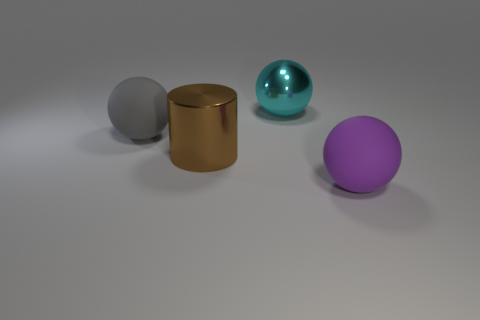Add 1 big brown blocks. How many objects exist? 5 Subtract all large gray spheres. How many spheres are left? 2 Subtract all purple balls. How many balls are left? 2 Subtract all spheres. How many objects are left? 1 Subtract 1 cylinders. How many cylinders are left? 0 Add 1 large brown cylinders. How many large brown cylinders exist? 2 Subtract 0 cyan cubes. How many objects are left? 4 Subtract all blue spheres. Subtract all purple cylinders. How many spheres are left? 3 Subtract all brown cubes. How many cyan balls are left? 1 Subtract all big matte balls. Subtract all big cyan shiny objects. How many objects are left? 1 